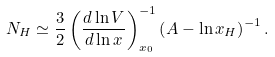<formula> <loc_0><loc_0><loc_500><loc_500>N _ { H } \simeq \frac { 3 } { 2 } \left ( \frac { d \ln V } { d \ln x } \right ) _ { x _ { 0 } } ^ { - 1 } \left ( A - \ln x _ { H } \right ) ^ { - 1 } .</formula> 